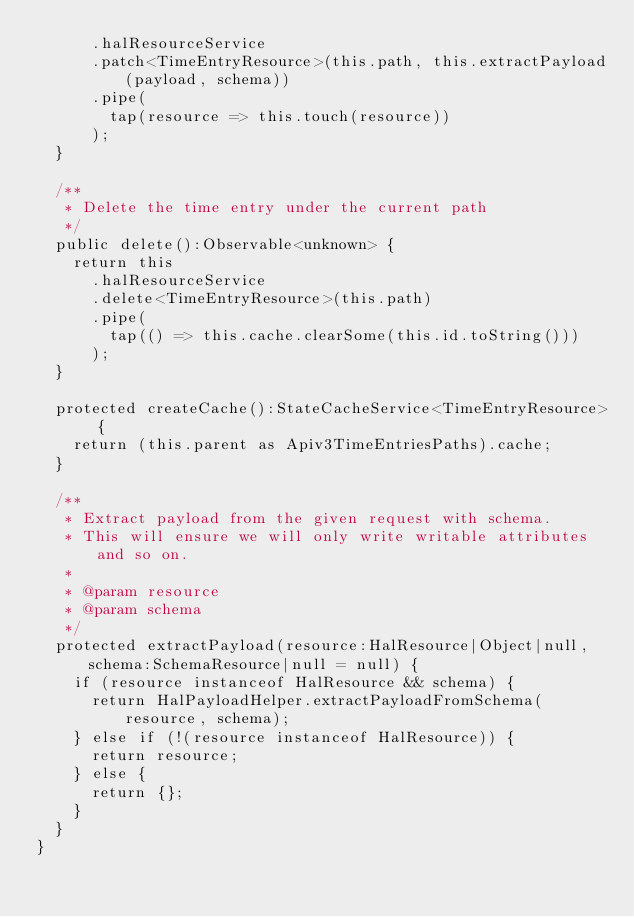<code> <loc_0><loc_0><loc_500><loc_500><_TypeScript_>      .halResourceService
      .patch<TimeEntryResource>(this.path, this.extractPayload(payload, schema))
      .pipe(
        tap(resource => this.touch(resource))
      );
  }

  /**
   * Delete the time entry under the current path
   */
  public delete():Observable<unknown> {
    return this
      .halResourceService
      .delete<TimeEntryResource>(this.path)
      .pipe(
        tap(() => this.cache.clearSome(this.id.toString()))
      );
  }

  protected createCache():StateCacheService<TimeEntryResource> {
    return (this.parent as Apiv3TimeEntriesPaths).cache;
  }

  /**
   * Extract payload from the given request with schema.
   * This will ensure we will only write writable attributes and so on.
   *
   * @param resource
   * @param schema
   */
  protected extractPayload(resource:HalResource|Object|null, schema:SchemaResource|null = null) {
    if (resource instanceof HalResource && schema) {
      return HalPayloadHelper.extractPayloadFromSchema(resource, schema);
    } else if (!(resource instanceof HalResource)) {
      return resource;
    } else {
      return {};
    }
  }
}
</code> 